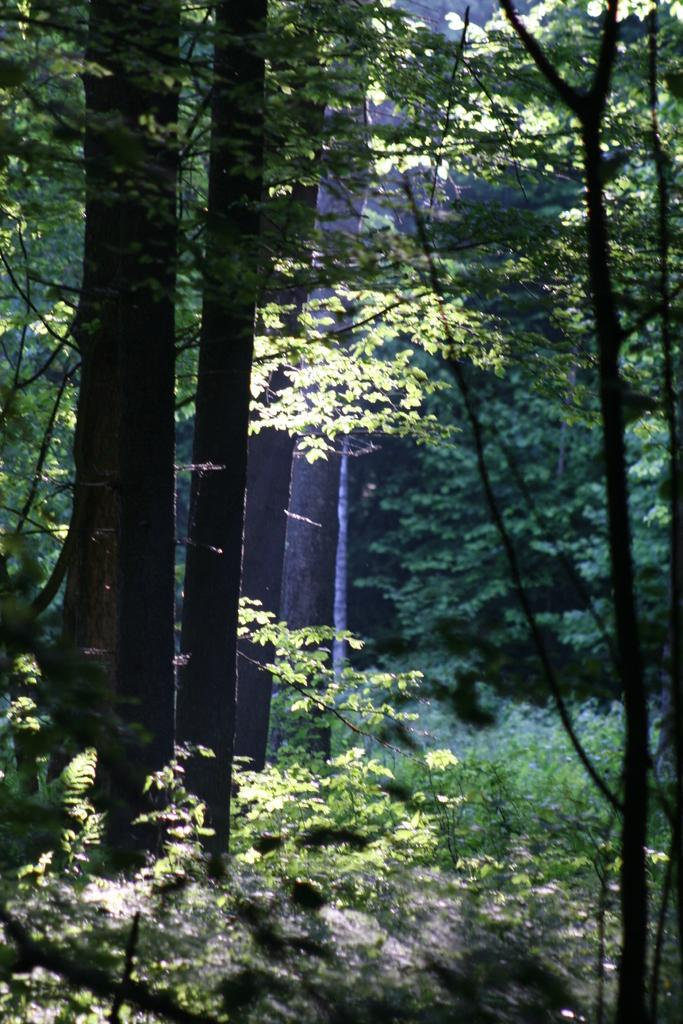What type of vegetation is visible in the image? There are trees and plants visible in the image. Can you describe the setting in which the trees and plants are located? The setting is not specified, but the presence of trees and plants suggests a natural environment. Where is the secretary located in the image? There is no secretary present in the image. What type of basin can be seen holding water in the image? There is no basin present in the image. 